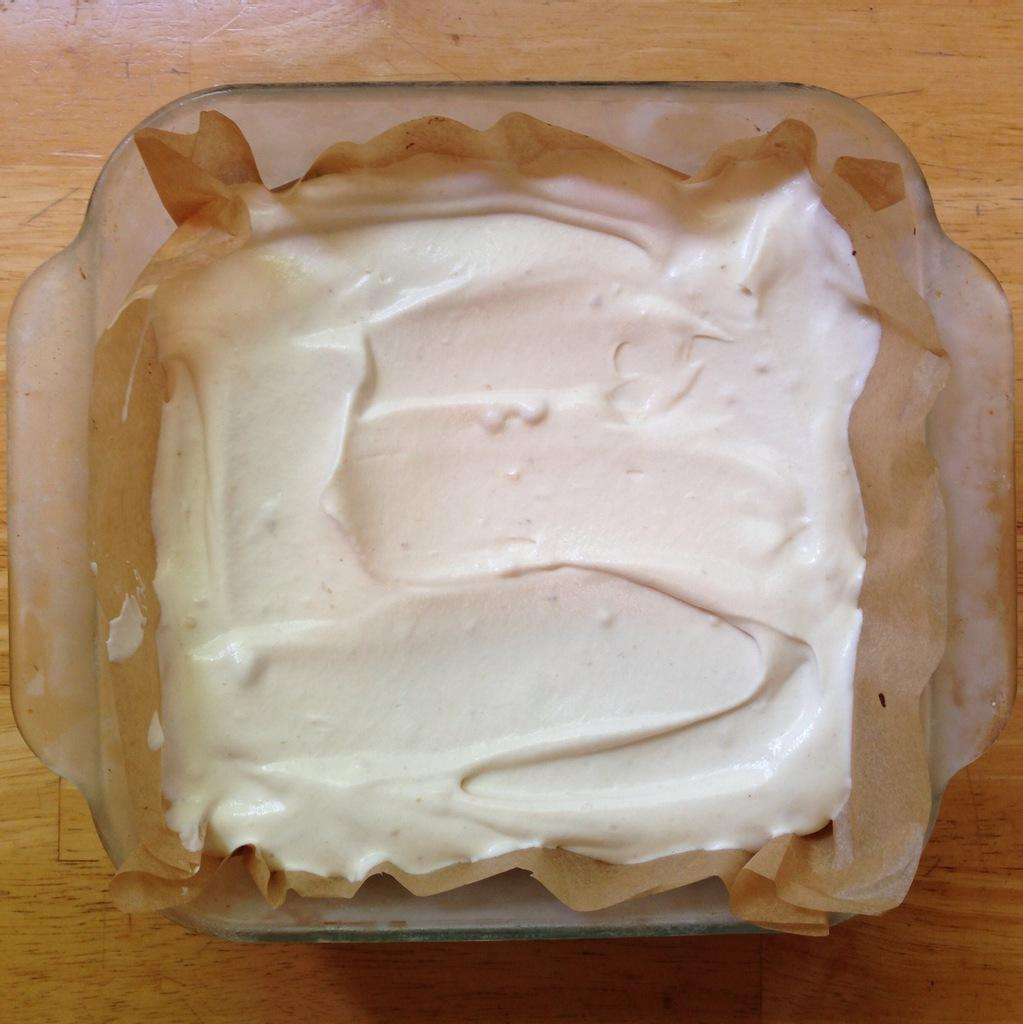What type of container is present in the image? There is a glass bowl in the image. What is inside the glass bowl? There is a brown-colored paper and white cream in the bowl. How many eggs are present in the image? There are no eggs visible in the image. 